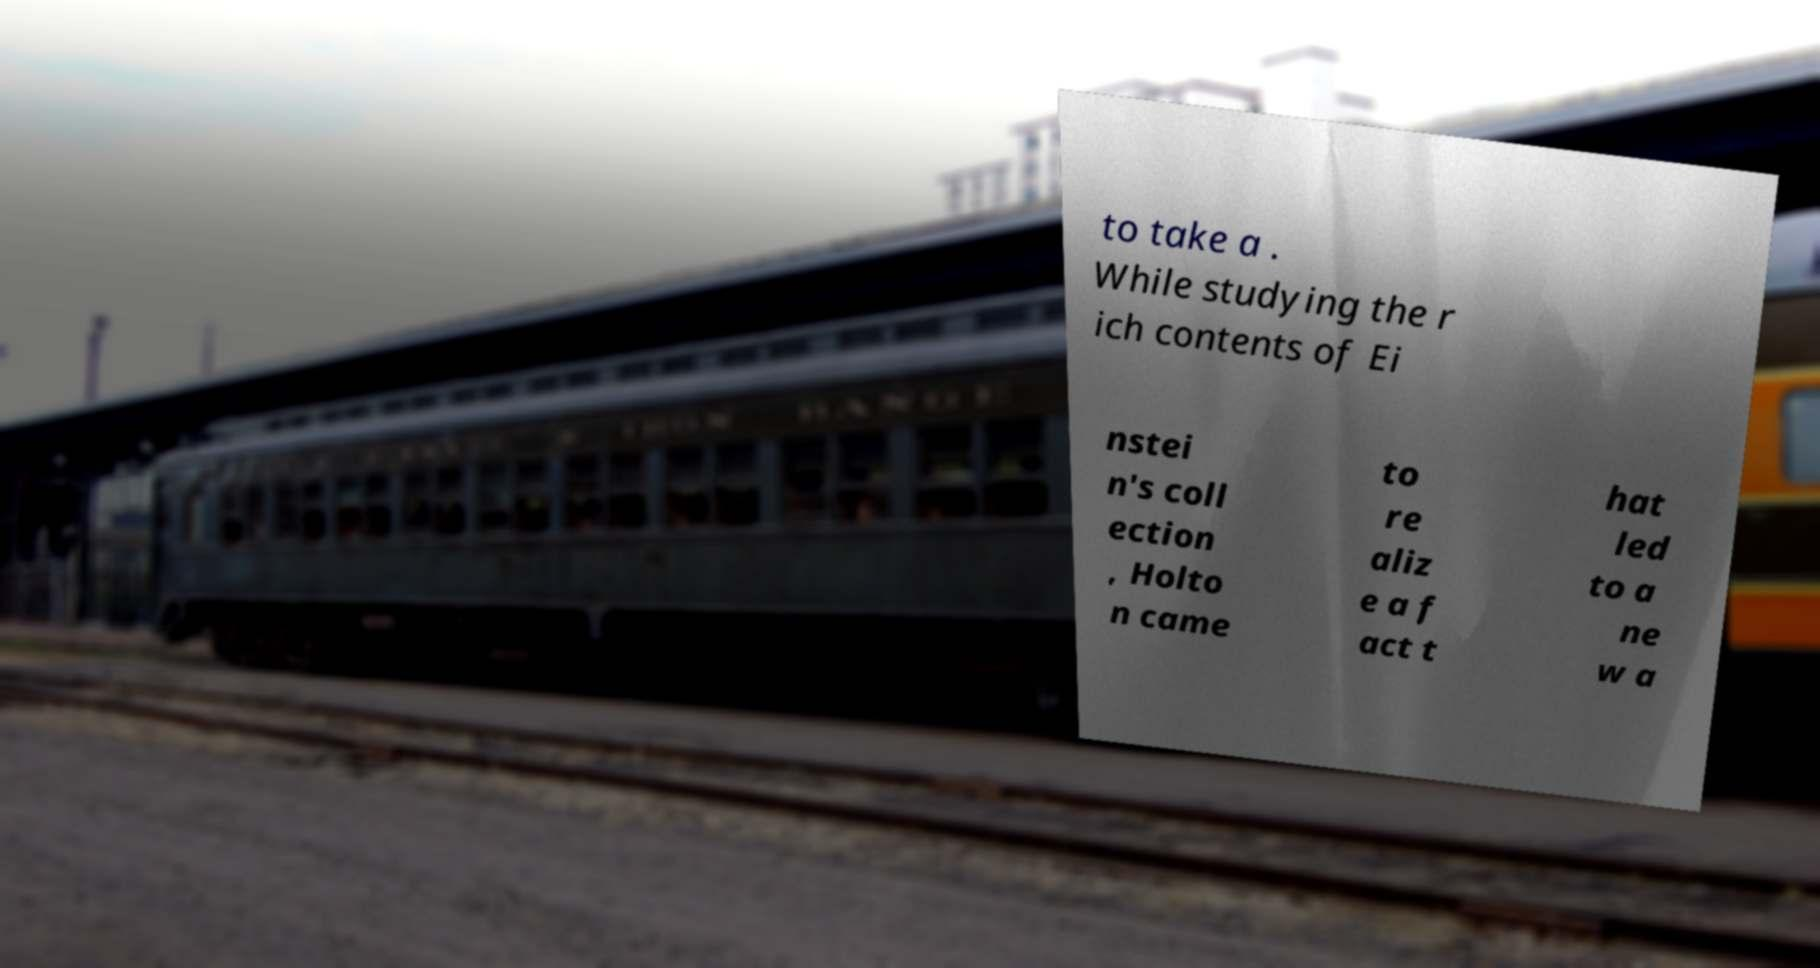I need the written content from this picture converted into text. Can you do that? to take a . While studying the r ich contents of Ei nstei n's coll ection , Holto n came to re aliz e a f act t hat led to a ne w a 